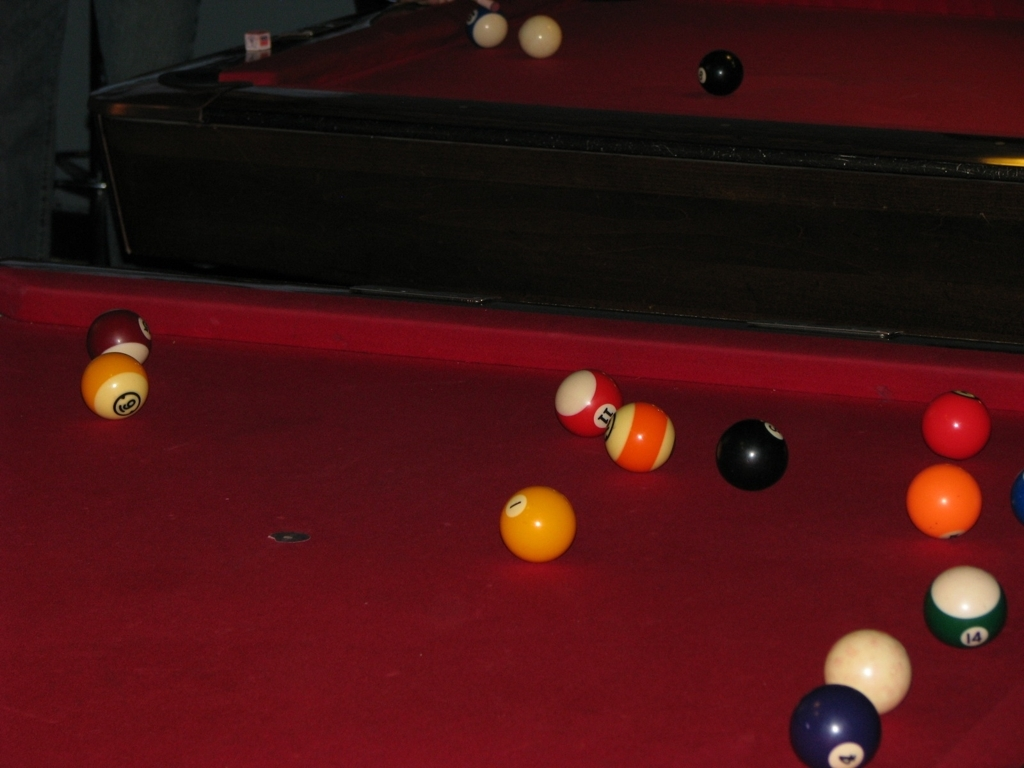Can you infer anything about the location or setting from the image? Based on the red felt of the pool table and the dim lighting, the setting could be a bar, pub, or recreational room. The lack of people in the immediate vicinity implies that the players may have stepped away temporarily, or the venue is not crowded. What details in the background could provide more context? The image shows a corner of the room with a shelf in the background that might hold cues or other gaming accessories. The absence of windows or other distinctive decor makes it difficult to ascertain more specific details about the location. 